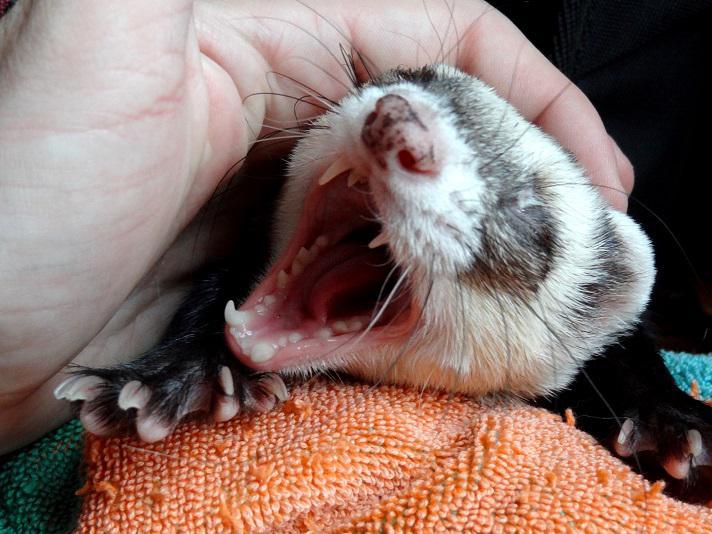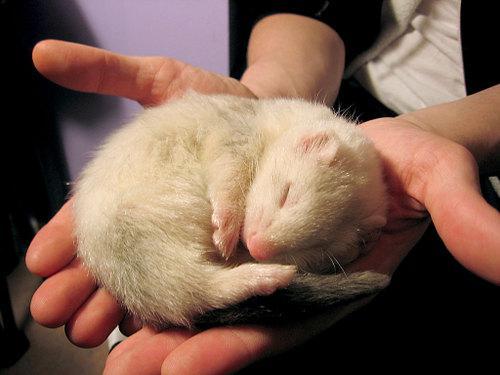The first image is the image on the left, the second image is the image on the right. Considering the images on both sides, is "There is one ferret in the right image with its eyes closed." valid? Answer yes or no. Yes. The first image is the image on the left, the second image is the image on the right. For the images displayed, is the sentence "There is at least one white ferreton a blanket with another ferret." factually correct? Answer yes or no. No. 